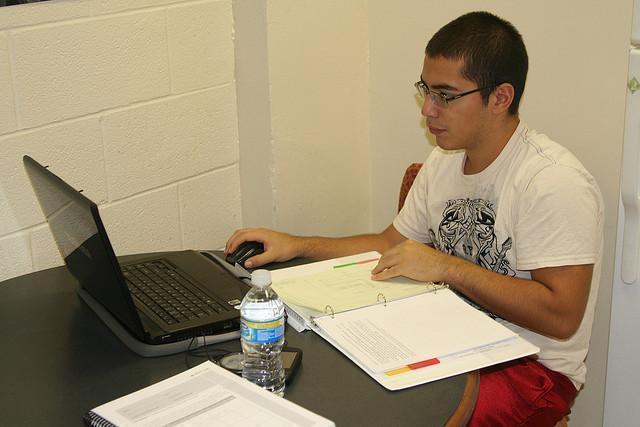Where is this student studying?
Select the accurate answer and provide justification: `Answer: choice
Rationale: srationale.`
Options: Dormitory, apartment, library, library. Answer: dormitory.
Rationale: The student is studying in a college dorm room. 